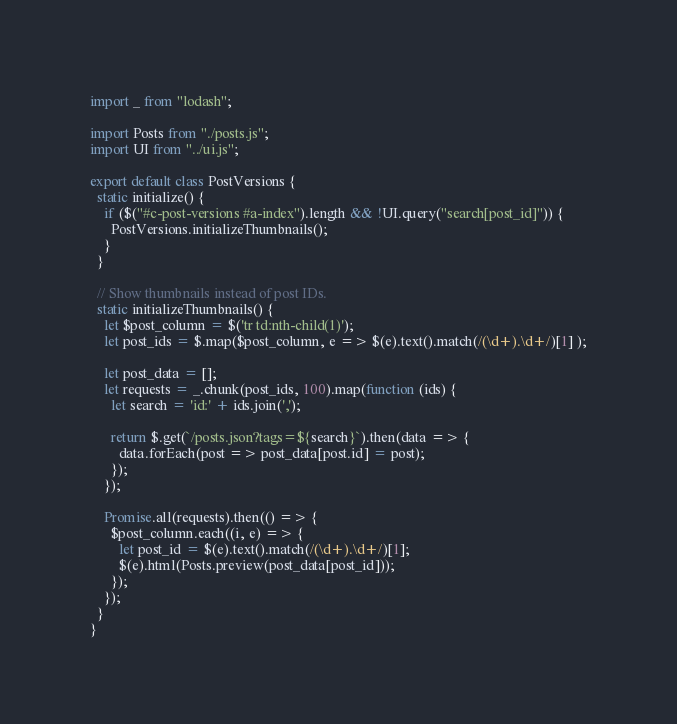Convert code to text. <code><loc_0><loc_0><loc_500><loc_500><_JavaScript_>import _ from "lodash";

import Posts from "./posts.js";
import UI from "../ui.js";

export default class PostVersions {
  static initialize() {
    if ($("#c-post-versions #a-index").length && !UI.query("search[post_id]")) {
      PostVersions.initializeThumbnails();
    }
  }

  // Show thumbnails instead of post IDs.
  static initializeThumbnails() {
    let $post_column = $('tr td:nth-child(1)');
    let post_ids = $.map($post_column, e => $(e).text().match(/(\d+).\d+/)[1] );

    let post_data = [];
    let requests = _.chunk(post_ids, 100).map(function (ids) {
      let search = 'id:' + ids.join(',');

      return $.get(`/posts.json?tags=${search}`).then(data => {
        data.forEach(post => post_data[post.id] = post);
      });
    });

    Promise.all(requests).then(() => {
      $post_column.each((i, e) => {
        let post_id = $(e).text().match(/(\d+).\d+/)[1];
        $(e).html(Posts.preview(post_data[post_id]));
      });
    });
  }
}
</code> 